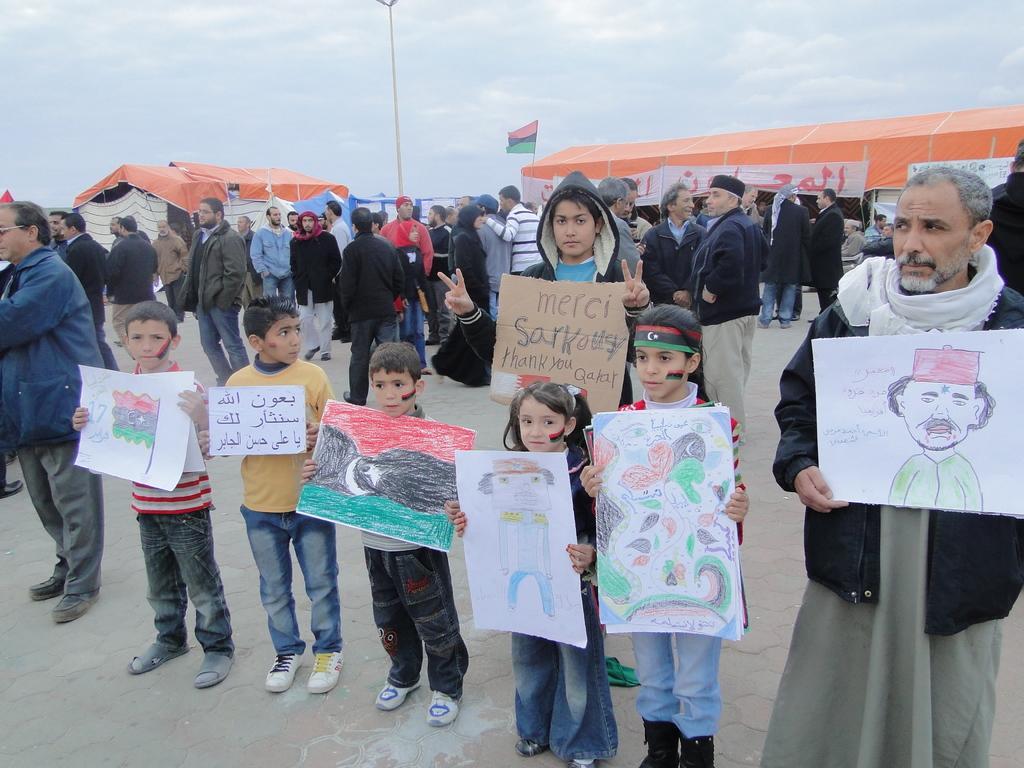Can you describe this image briefly? In this picture I can see group of people standing, few people are holding papers, there are canopy tents, banners, there is a flag, and in the background there is the sky. 